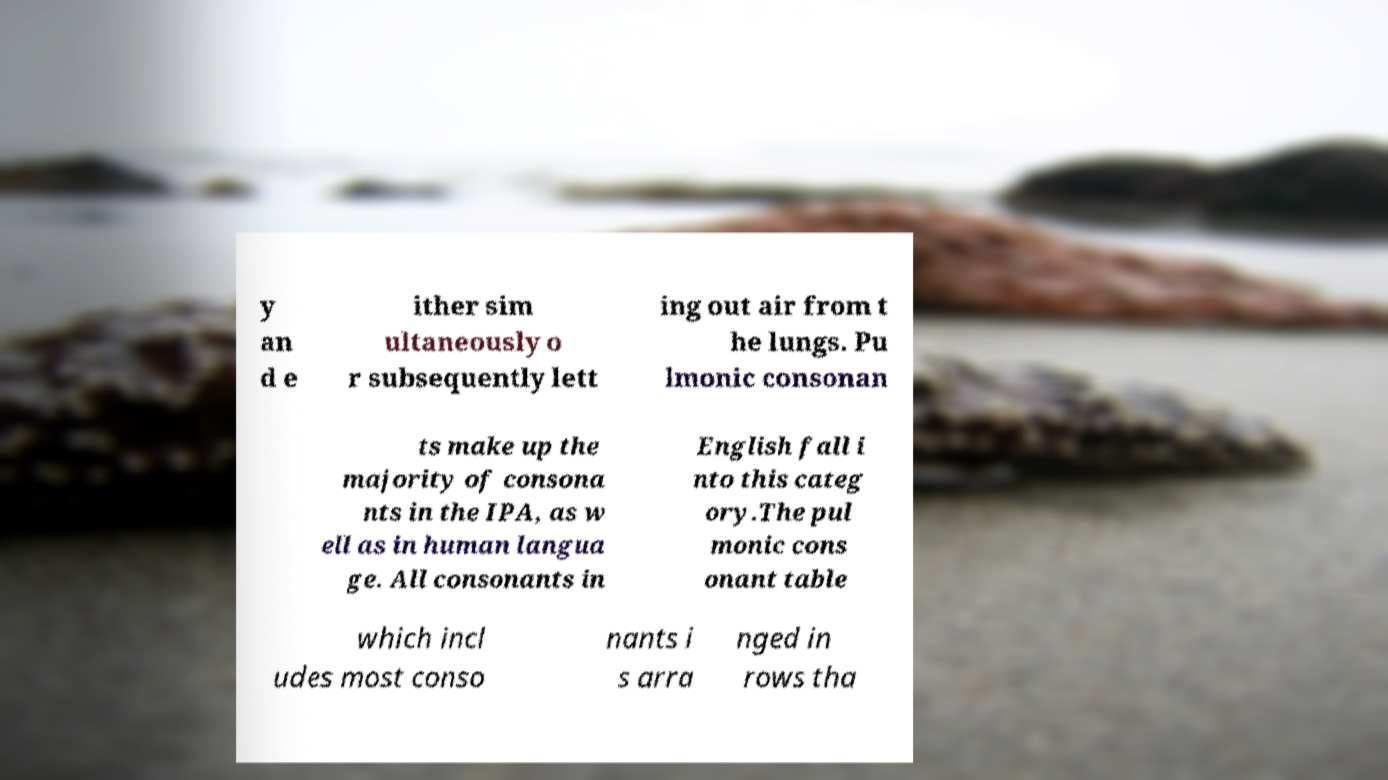Please read and relay the text visible in this image. What does it say? y an d e ither sim ultaneously o r subsequently lett ing out air from t he lungs. Pu lmonic consonan ts make up the majority of consona nts in the IPA, as w ell as in human langua ge. All consonants in English fall i nto this categ ory.The pul monic cons onant table which incl udes most conso nants i s arra nged in rows tha 